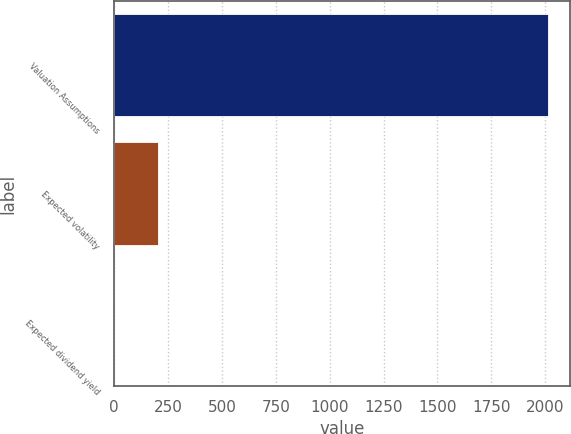Convert chart to OTSL. <chart><loc_0><loc_0><loc_500><loc_500><bar_chart><fcel>Valuation Assumptions<fcel>Expected volatility<fcel>Expected dividend yield<nl><fcel>2014<fcel>201.47<fcel>0.08<nl></chart> 